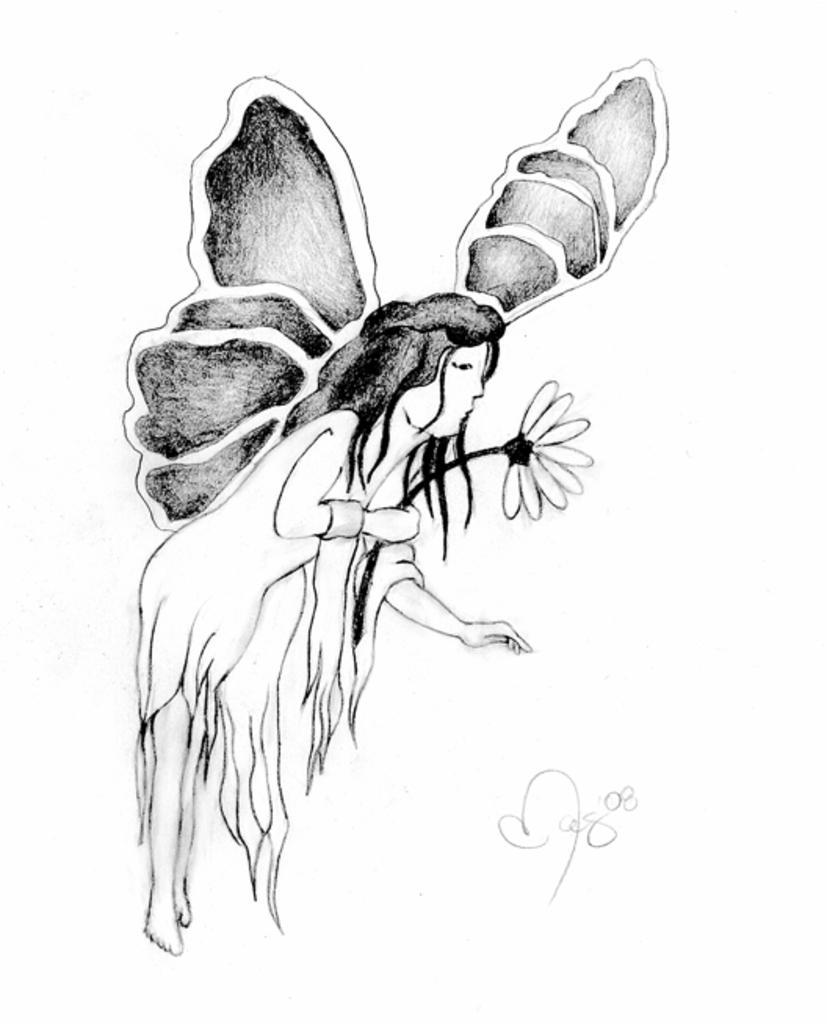Describe this image in one or two sentences. This is a sketch. In this picture we can see a woman having wings on her back and holding a flower in her hand. There is some text visible on the right side. Background is white in color. 